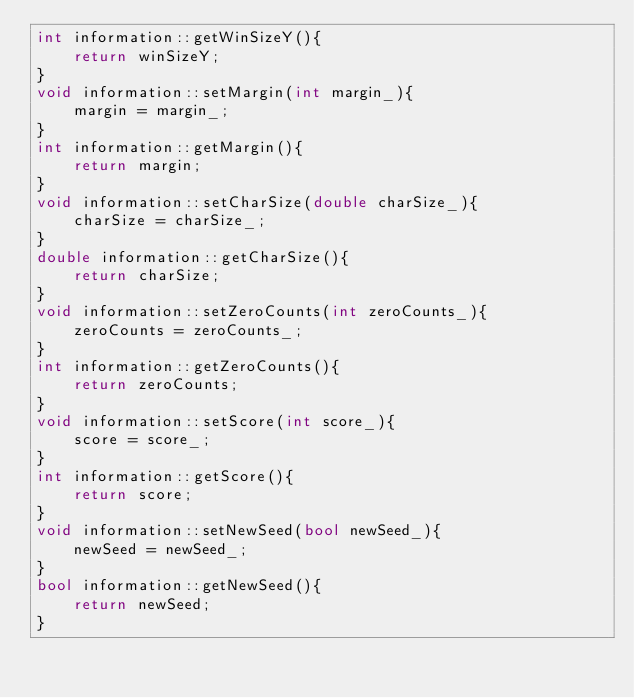Convert code to text. <code><loc_0><loc_0><loc_500><loc_500><_C++_>int information::getWinSizeY(){
    return winSizeY;
}
void information::setMargin(int margin_){
    margin = margin_;
}
int information::getMargin(){
    return margin;
}
void information::setCharSize(double charSize_){
    charSize = charSize_;
}
double information::getCharSize(){
    return charSize;
}
void information::setZeroCounts(int zeroCounts_){
    zeroCounts = zeroCounts_;
}
int information::getZeroCounts(){
    return zeroCounts;
}
void information::setScore(int score_){
    score = score_;
}
int information::getScore(){
    return score;
}
void information::setNewSeed(bool newSeed_){
    newSeed = newSeed_;
}
bool information::getNewSeed(){
    return newSeed;
}
</code> 